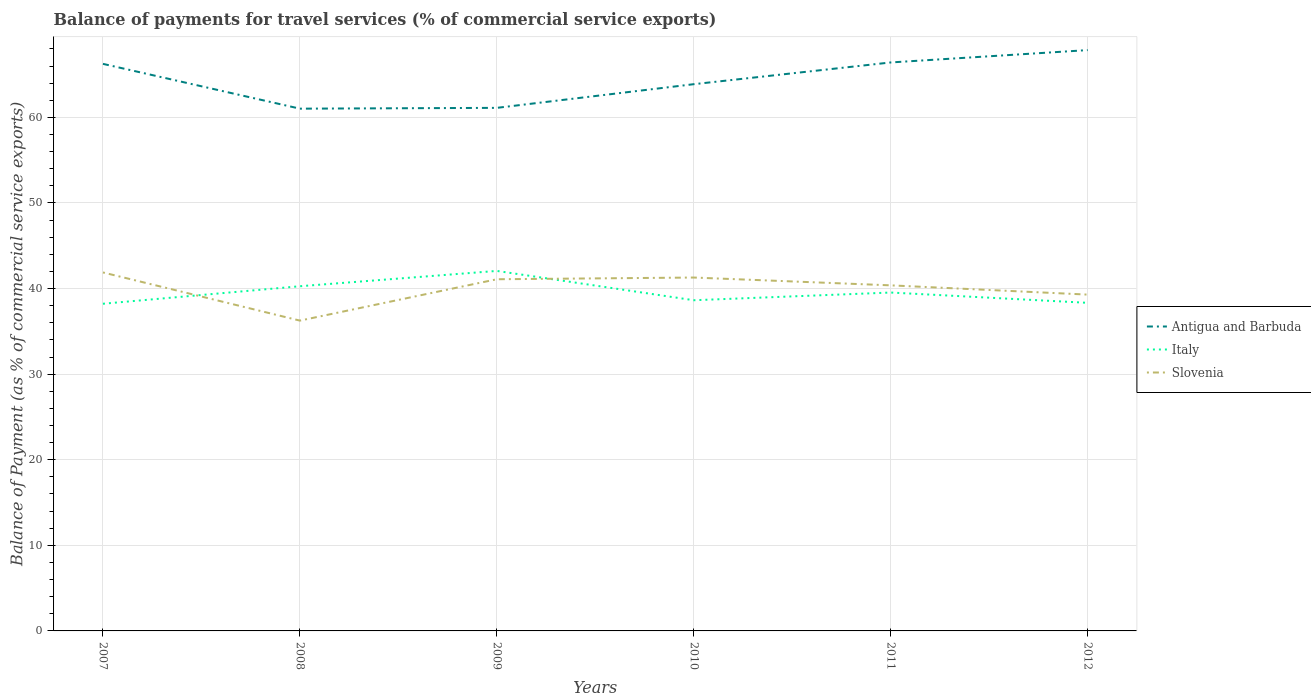How many different coloured lines are there?
Your answer should be compact. 3. Is the number of lines equal to the number of legend labels?
Ensure brevity in your answer.  Yes. Across all years, what is the maximum balance of payments for travel services in Antigua and Barbuda?
Your answer should be very brief. 61.02. In which year was the balance of payments for travel services in Italy maximum?
Give a very brief answer. 2007. What is the total balance of payments for travel services in Italy in the graph?
Your answer should be very brief. 1.63. What is the difference between the highest and the second highest balance of payments for travel services in Italy?
Give a very brief answer. 3.84. What is the difference between the highest and the lowest balance of payments for travel services in Antigua and Barbuda?
Provide a succinct answer. 3. How many lines are there?
Your answer should be compact. 3. How many years are there in the graph?
Offer a very short reply. 6. What is the difference between two consecutive major ticks on the Y-axis?
Keep it short and to the point. 10. Does the graph contain any zero values?
Ensure brevity in your answer.  No. Does the graph contain grids?
Offer a terse response. Yes. Where does the legend appear in the graph?
Give a very brief answer. Center right. How many legend labels are there?
Your answer should be compact. 3. What is the title of the graph?
Keep it short and to the point. Balance of payments for travel services (% of commercial service exports). Does "Malta" appear as one of the legend labels in the graph?
Provide a short and direct response. No. What is the label or title of the X-axis?
Your answer should be compact. Years. What is the label or title of the Y-axis?
Your answer should be compact. Balance of Payment (as % of commercial service exports). What is the Balance of Payment (as % of commercial service exports) in Antigua and Barbuda in 2007?
Keep it short and to the point. 66.25. What is the Balance of Payment (as % of commercial service exports) in Italy in 2007?
Ensure brevity in your answer.  38.22. What is the Balance of Payment (as % of commercial service exports) in Slovenia in 2007?
Your response must be concise. 41.88. What is the Balance of Payment (as % of commercial service exports) of Antigua and Barbuda in 2008?
Give a very brief answer. 61.02. What is the Balance of Payment (as % of commercial service exports) of Italy in 2008?
Your answer should be compact. 40.27. What is the Balance of Payment (as % of commercial service exports) of Slovenia in 2008?
Offer a terse response. 36.25. What is the Balance of Payment (as % of commercial service exports) in Antigua and Barbuda in 2009?
Offer a very short reply. 61.11. What is the Balance of Payment (as % of commercial service exports) of Italy in 2009?
Offer a very short reply. 42.06. What is the Balance of Payment (as % of commercial service exports) of Slovenia in 2009?
Make the answer very short. 41.09. What is the Balance of Payment (as % of commercial service exports) in Antigua and Barbuda in 2010?
Keep it short and to the point. 63.88. What is the Balance of Payment (as % of commercial service exports) in Italy in 2010?
Give a very brief answer. 38.64. What is the Balance of Payment (as % of commercial service exports) in Slovenia in 2010?
Your answer should be very brief. 41.29. What is the Balance of Payment (as % of commercial service exports) of Antigua and Barbuda in 2011?
Provide a short and direct response. 66.42. What is the Balance of Payment (as % of commercial service exports) of Italy in 2011?
Offer a very short reply. 39.53. What is the Balance of Payment (as % of commercial service exports) in Slovenia in 2011?
Provide a short and direct response. 40.37. What is the Balance of Payment (as % of commercial service exports) in Antigua and Barbuda in 2012?
Provide a succinct answer. 67.86. What is the Balance of Payment (as % of commercial service exports) in Italy in 2012?
Keep it short and to the point. 38.33. What is the Balance of Payment (as % of commercial service exports) of Slovenia in 2012?
Offer a very short reply. 39.29. Across all years, what is the maximum Balance of Payment (as % of commercial service exports) in Antigua and Barbuda?
Provide a short and direct response. 67.86. Across all years, what is the maximum Balance of Payment (as % of commercial service exports) in Italy?
Keep it short and to the point. 42.06. Across all years, what is the maximum Balance of Payment (as % of commercial service exports) of Slovenia?
Make the answer very short. 41.88. Across all years, what is the minimum Balance of Payment (as % of commercial service exports) of Antigua and Barbuda?
Your answer should be very brief. 61.02. Across all years, what is the minimum Balance of Payment (as % of commercial service exports) in Italy?
Give a very brief answer. 38.22. Across all years, what is the minimum Balance of Payment (as % of commercial service exports) of Slovenia?
Make the answer very short. 36.25. What is the total Balance of Payment (as % of commercial service exports) in Antigua and Barbuda in the graph?
Your response must be concise. 386.53. What is the total Balance of Payment (as % of commercial service exports) of Italy in the graph?
Ensure brevity in your answer.  237.06. What is the total Balance of Payment (as % of commercial service exports) in Slovenia in the graph?
Offer a terse response. 240.17. What is the difference between the Balance of Payment (as % of commercial service exports) of Antigua and Barbuda in 2007 and that in 2008?
Your answer should be very brief. 5.23. What is the difference between the Balance of Payment (as % of commercial service exports) of Italy in 2007 and that in 2008?
Offer a very short reply. -2.05. What is the difference between the Balance of Payment (as % of commercial service exports) in Slovenia in 2007 and that in 2008?
Offer a terse response. 5.63. What is the difference between the Balance of Payment (as % of commercial service exports) in Antigua and Barbuda in 2007 and that in 2009?
Provide a succinct answer. 5.14. What is the difference between the Balance of Payment (as % of commercial service exports) of Italy in 2007 and that in 2009?
Provide a succinct answer. -3.84. What is the difference between the Balance of Payment (as % of commercial service exports) of Slovenia in 2007 and that in 2009?
Give a very brief answer. 0.79. What is the difference between the Balance of Payment (as % of commercial service exports) of Antigua and Barbuda in 2007 and that in 2010?
Offer a terse response. 2.37. What is the difference between the Balance of Payment (as % of commercial service exports) in Italy in 2007 and that in 2010?
Your answer should be very brief. -0.41. What is the difference between the Balance of Payment (as % of commercial service exports) of Slovenia in 2007 and that in 2010?
Give a very brief answer. 0.59. What is the difference between the Balance of Payment (as % of commercial service exports) in Antigua and Barbuda in 2007 and that in 2011?
Provide a succinct answer. -0.17. What is the difference between the Balance of Payment (as % of commercial service exports) of Italy in 2007 and that in 2011?
Provide a short and direct response. -1.31. What is the difference between the Balance of Payment (as % of commercial service exports) of Slovenia in 2007 and that in 2011?
Ensure brevity in your answer.  1.51. What is the difference between the Balance of Payment (as % of commercial service exports) of Antigua and Barbuda in 2007 and that in 2012?
Provide a succinct answer. -1.61. What is the difference between the Balance of Payment (as % of commercial service exports) in Italy in 2007 and that in 2012?
Make the answer very short. -0.11. What is the difference between the Balance of Payment (as % of commercial service exports) of Slovenia in 2007 and that in 2012?
Your response must be concise. 2.59. What is the difference between the Balance of Payment (as % of commercial service exports) in Antigua and Barbuda in 2008 and that in 2009?
Offer a terse response. -0.09. What is the difference between the Balance of Payment (as % of commercial service exports) of Italy in 2008 and that in 2009?
Offer a terse response. -1.79. What is the difference between the Balance of Payment (as % of commercial service exports) of Slovenia in 2008 and that in 2009?
Give a very brief answer. -4.83. What is the difference between the Balance of Payment (as % of commercial service exports) of Antigua and Barbuda in 2008 and that in 2010?
Provide a short and direct response. -2.86. What is the difference between the Balance of Payment (as % of commercial service exports) of Italy in 2008 and that in 2010?
Give a very brief answer. 1.63. What is the difference between the Balance of Payment (as % of commercial service exports) of Slovenia in 2008 and that in 2010?
Offer a terse response. -5.03. What is the difference between the Balance of Payment (as % of commercial service exports) in Antigua and Barbuda in 2008 and that in 2011?
Offer a very short reply. -5.4. What is the difference between the Balance of Payment (as % of commercial service exports) of Italy in 2008 and that in 2011?
Your response must be concise. 0.74. What is the difference between the Balance of Payment (as % of commercial service exports) in Slovenia in 2008 and that in 2011?
Ensure brevity in your answer.  -4.12. What is the difference between the Balance of Payment (as % of commercial service exports) of Antigua and Barbuda in 2008 and that in 2012?
Your response must be concise. -6.84. What is the difference between the Balance of Payment (as % of commercial service exports) in Italy in 2008 and that in 2012?
Your response must be concise. 1.94. What is the difference between the Balance of Payment (as % of commercial service exports) of Slovenia in 2008 and that in 2012?
Your answer should be very brief. -3.04. What is the difference between the Balance of Payment (as % of commercial service exports) in Antigua and Barbuda in 2009 and that in 2010?
Ensure brevity in your answer.  -2.77. What is the difference between the Balance of Payment (as % of commercial service exports) in Italy in 2009 and that in 2010?
Offer a very short reply. 3.42. What is the difference between the Balance of Payment (as % of commercial service exports) of Slovenia in 2009 and that in 2010?
Ensure brevity in your answer.  -0.2. What is the difference between the Balance of Payment (as % of commercial service exports) of Antigua and Barbuda in 2009 and that in 2011?
Give a very brief answer. -5.3. What is the difference between the Balance of Payment (as % of commercial service exports) of Italy in 2009 and that in 2011?
Ensure brevity in your answer.  2.53. What is the difference between the Balance of Payment (as % of commercial service exports) in Slovenia in 2009 and that in 2011?
Your answer should be compact. 0.71. What is the difference between the Balance of Payment (as % of commercial service exports) in Antigua and Barbuda in 2009 and that in 2012?
Your answer should be very brief. -6.75. What is the difference between the Balance of Payment (as % of commercial service exports) in Italy in 2009 and that in 2012?
Make the answer very short. 3.73. What is the difference between the Balance of Payment (as % of commercial service exports) of Slovenia in 2009 and that in 2012?
Make the answer very short. 1.79. What is the difference between the Balance of Payment (as % of commercial service exports) in Antigua and Barbuda in 2010 and that in 2011?
Ensure brevity in your answer.  -2.54. What is the difference between the Balance of Payment (as % of commercial service exports) in Italy in 2010 and that in 2011?
Offer a very short reply. -0.9. What is the difference between the Balance of Payment (as % of commercial service exports) in Slovenia in 2010 and that in 2011?
Ensure brevity in your answer.  0.91. What is the difference between the Balance of Payment (as % of commercial service exports) of Antigua and Barbuda in 2010 and that in 2012?
Give a very brief answer. -3.98. What is the difference between the Balance of Payment (as % of commercial service exports) in Italy in 2010 and that in 2012?
Give a very brief answer. 0.3. What is the difference between the Balance of Payment (as % of commercial service exports) in Slovenia in 2010 and that in 2012?
Offer a terse response. 1.99. What is the difference between the Balance of Payment (as % of commercial service exports) in Antigua and Barbuda in 2011 and that in 2012?
Make the answer very short. -1.44. What is the difference between the Balance of Payment (as % of commercial service exports) in Italy in 2011 and that in 2012?
Offer a terse response. 1.2. What is the difference between the Balance of Payment (as % of commercial service exports) of Slovenia in 2011 and that in 2012?
Your answer should be compact. 1.08. What is the difference between the Balance of Payment (as % of commercial service exports) in Antigua and Barbuda in 2007 and the Balance of Payment (as % of commercial service exports) in Italy in 2008?
Your answer should be very brief. 25.98. What is the difference between the Balance of Payment (as % of commercial service exports) in Antigua and Barbuda in 2007 and the Balance of Payment (as % of commercial service exports) in Slovenia in 2008?
Your answer should be compact. 30. What is the difference between the Balance of Payment (as % of commercial service exports) in Italy in 2007 and the Balance of Payment (as % of commercial service exports) in Slovenia in 2008?
Your answer should be very brief. 1.97. What is the difference between the Balance of Payment (as % of commercial service exports) of Antigua and Barbuda in 2007 and the Balance of Payment (as % of commercial service exports) of Italy in 2009?
Give a very brief answer. 24.19. What is the difference between the Balance of Payment (as % of commercial service exports) in Antigua and Barbuda in 2007 and the Balance of Payment (as % of commercial service exports) in Slovenia in 2009?
Keep it short and to the point. 25.16. What is the difference between the Balance of Payment (as % of commercial service exports) in Italy in 2007 and the Balance of Payment (as % of commercial service exports) in Slovenia in 2009?
Keep it short and to the point. -2.86. What is the difference between the Balance of Payment (as % of commercial service exports) in Antigua and Barbuda in 2007 and the Balance of Payment (as % of commercial service exports) in Italy in 2010?
Offer a terse response. 27.62. What is the difference between the Balance of Payment (as % of commercial service exports) of Antigua and Barbuda in 2007 and the Balance of Payment (as % of commercial service exports) of Slovenia in 2010?
Ensure brevity in your answer.  24.96. What is the difference between the Balance of Payment (as % of commercial service exports) of Italy in 2007 and the Balance of Payment (as % of commercial service exports) of Slovenia in 2010?
Give a very brief answer. -3.06. What is the difference between the Balance of Payment (as % of commercial service exports) of Antigua and Barbuda in 2007 and the Balance of Payment (as % of commercial service exports) of Italy in 2011?
Ensure brevity in your answer.  26.72. What is the difference between the Balance of Payment (as % of commercial service exports) of Antigua and Barbuda in 2007 and the Balance of Payment (as % of commercial service exports) of Slovenia in 2011?
Make the answer very short. 25.88. What is the difference between the Balance of Payment (as % of commercial service exports) in Italy in 2007 and the Balance of Payment (as % of commercial service exports) in Slovenia in 2011?
Provide a succinct answer. -2.15. What is the difference between the Balance of Payment (as % of commercial service exports) of Antigua and Barbuda in 2007 and the Balance of Payment (as % of commercial service exports) of Italy in 2012?
Your answer should be compact. 27.92. What is the difference between the Balance of Payment (as % of commercial service exports) of Antigua and Barbuda in 2007 and the Balance of Payment (as % of commercial service exports) of Slovenia in 2012?
Your response must be concise. 26.96. What is the difference between the Balance of Payment (as % of commercial service exports) of Italy in 2007 and the Balance of Payment (as % of commercial service exports) of Slovenia in 2012?
Provide a succinct answer. -1.07. What is the difference between the Balance of Payment (as % of commercial service exports) of Antigua and Barbuda in 2008 and the Balance of Payment (as % of commercial service exports) of Italy in 2009?
Give a very brief answer. 18.96. What is the difference between the Balance of Payment (as % of commercial service exports) in Antigua and Barbuda in 2008 and the Balance of Payment (as % of commercial service exports) in Slovenia in 2009?
Ensure brevity in your answer.  19.93. What is the difference between the Balance of Payment (as % of commercial service exports) in Italy in 2008 and the Balance of Payment (as % of commercial service exports) in Slovenia in 2009?
Provide a succinct answer. -0.82. What is the difference between the Balance of Payment (as % of commercial service exports) of Antigua and Barbuda in 2008 and the Balance of Payment (as % of commercial service exports) of Italy in 2010?
Your response must be concise. 22.38. What is the difference between the Balance of Payment (as % of commercial service exports) in Antigua and Barbuda in 2008 and the Balance of Payment (as % of commercial service exports) in Slovenia in 2010?
Your answer should be very brief. 19.73. What is the difference between the Balance of Payment (as % of commercial service exports) of Italy in 2008 and the Balance of Payment (as % of commercial service exports) of Slovenia in 2010?
Your response must be concise. -1.02. What is the difference between the Balance of Payment (as % of commercial service exports) of Antigua and Barbuda in 2008 and the Balance of Payment (as % of commercial service exports) of Italy in 2011?
Make the answer very short. 21.48. What is the difference between the Balance of Payment (as % of commercial service exports) of Antigua and Barbuda in 2008 and the Balance of Payment (as % of commercial service exports) of Slovenia in 2011?
Provide a succinct answer. 20.64. What is the difference between the Balance of Payment (as % of commercial service exports) of Italy in 2008 and the Balance of Payment (as % of commercial service exports) of Slovenia in 2011?
Your response must be concise. -0.1. What is the difference between the Balance of Payment (as % of commercial service exports) of Antigua and Barbuda in 2008 and the Balance of Payment (as % of commercial service exports) of Italy in 2012?
Ensure brevity in your answer.  22.68. What is the difference between the Balance of Payment (as % of commercial service exports) of Antigua and Barbuda in 2008 and the Balance of Payment (as % of commercial service exports) of Slovenia in 2012?
Offer a terse response. 21.72. What is the difference between the Balance of Payment (as % of commercial service exports) of Italy in 2008 and the Balance of Payment (as % of commercial service exports) of Slovenia in 2012?
Make the answer very short. 0.98. What is the difference between the Balance of Payment (as % of commercial service exports) of Antigua and Barbuda in 2009 and the Balance of Payment (as % of commercial service exports) of Italy in 2010?
Offer a terse response. 22.48. What is the difference between the Balance of Payment (as % of commercial service exports) of Antigua and Barbuda in 2009 and the Balance of Payment (as % of commercial service exports) of Slovenia in 2010?
Keep it short and to the point. 19.82. What is the difference between the Balance of Payment (as % of commercial service exports) in Italy in 2009 and the Balance of Payment (as % of commercial service exports) in Slovenia in 2010?
Your answer should be very brief. 0.77. What is the difference between the Balance of Payment (as % of commercial service exports) of Antigua and Barbuda in 2009 and the Balance of Payment (as % of commercial service exports) of Italy in 2011?
Your answer should be very brief. 21.58. What is the difference between the Balance of Payment (as % of commercial service exports) in Antigua and Barbuda in 2009 and the Balance of Payment (as % of commercial service exports) in Slovenia in 2011?
Your answer should be very brief. 20.74. What is the difference between the Balance of Payment (as % of commercial service exports) of Italy in 2009 and the Balance of Payment (as % of commercial service exports) of Slovenia in 2011?
Your answer should be very brief. 1.69. What is the difference between the Balance of Payment (as % of commercial service exports) in Antigua and Barbuda in 2009 and the Balance of Payment (as % of commercial service exports) in Italy in 2012?
Your response must be concise. 22.78. What is the difference between the Balance of Payment (as % of commercial service exports) of Antigua and Barbuda in 2009 and the Balance of Payment (as % of commercial service exports) of Slovenia in 2012?
Make the answer very short. 21.82. What is the difference between the Balance of Payment (as % of commercial service exports) in Italy in 2009 and the Balance of Payment (as % of commercial service exports) in Slovenia in 2012?
Provide a short and direct response. 2.77. What is the difference between the Balance of Payment (as % of commercial service exports) of Antigua and Barbuda in 2010 and the Balance of Payment (as % of commercial service exports) of Italy in 2011?
Offer a terse response. 24.34. What is the difference between the Balance of Payment (as % of commercial service exports) of Antigua and Barbuda in 2010 and the Balance of Payment (as % of commercial service exports) of Slovenia in 2011?
Make the answer very short. 23.5. What is the difference between the Balance of Payment (as % of commercial service exports) in Italy in 2010 and the Balance of Payment (as % of commercial service exports) in Slovenia in 2011?
Give a very brief answer. -1.74. What is the difference between the Balance of Payment (as % of commercial service exports) in Antigua and Barbuda in 2010 and the Balance of Payment (as % of commercial service exports) in Italy in 2012?
Keep it short and to the point. 25.54. What is the difference between the Balance of Payment (as % of commercial service exports) in Antigua and Barbuda in 2010 and the Balance of Payment (as % of commercial service exports) in Slovenia in 2012?
Make the answer very short. 24.58. What is the difference between the Balance of Payment (as % of commercial service exports) of Italy in 2010 and the Balance of Payment (as % of commercial service exports) of Slovenia in 2012?
Provide a short and direct response. -0.66. What is the difference between the Balance of Payment (as % of commercial service exports) of Antigua and Barbuda in 2011 and the Balance of Payment (as % of commercial service exports) of Italy in 2012?
Offer a terse response. 28.08. What is the difference between the Balance of Payment (as % of commercial service exports) of Antigua and Barbuda in 2011 and the Balance of Payment (as % of commercial service exports) of Slovenia in 2012?
Your answer should be very brief. 27.12. What is the difference between the Balance of Payment (as % of commercial service exports) of Italy in 2011 and the Balance of Payment (as % of commercial service exports) of Slovenia in 2012?
Offer a very short reply. 0.24. What is the average Balance of Payment (as % of commercial service exports) in Antigua and Barbuda per year?
Give a very brief answer. 64.42. What is the average Balance of Payment (as % of commercial service exports) in Italy per year?
Offer a very short reply. 39.51. What is the average Balance of Payment (as % of commercial service exports) of Slovenia per year?
Give a very brief answer. 40.03. In the year 2007, what is the difference between the Balance of Payment (as % of commercial service exports) in Antigua and Barbuda and Balance of Payment (as % of commercial service exports) in Italy?
Give a very brief answer. 28.03. In the year 2007, what is the difference between the Balance of Payment (as % of commercial service exports) in Antigua and Barbuda and Balance of Payment (as % of commercial service exports) in Slovenia?
Your response must be concise. 24.37. In the year 2007, what is the difference between the Balance of Payment (as % of commercial service exports) of Italy and Balance of Payment (as % of commercial service exports) of Slovenia?
Your answer should be very brief. -3.66. In the year 2008, what is the difference between the Balance of Payment (as % of commercial service exports) of Antigua and Barbuda and Balance of Payment (as % of commercial service exports) of Italy?
Provide a succinct answer. 20.75. In the year 2008, what is the difference between the Balance of Payment (as % of commercial service exports) of Antigua and Barbuda and Balance of Payment (as % of commercial service exports) of Slovenia?
Provide a short and direct response. 24.76. In the year 2008, what is the difference between the Balance of Payment (as % of commercial service exports) of Italy and Balance of Payment (as % of commercial service exports) of Slovenia?
Your answer should be compact. 4.02. In the year 2009, what is the difference between the Balance of Payment (as % of commercial service exports) in Antigua and Barbuda and Balance of Payment (as % of commercial service exports) in Italy?
Ensure brevity in your answer.  19.05. In the year 2009, what is the difference between the Balance of Payment (as % of commercial service exports) in Antigua and Barbuda and Balance of Payment (as % of commercial service exports) in Slovenia?
Your response must be concise. 20.02. In the year 2009, what is the difference between the Balance of Payment (as % of commercial service exports) in Italy and Balance of Payment (as % of commercial service exports) in Slovenia?
Give a very brief answer. 0.97. In the year 2010, what is the difference between the Balance of Payment (as % of commercial service exports) of Antigua and Barbuda and Balance of Payment (as % of commercial service exports) of Italy?
Keep it short and to the point. 25.24. In the year 2010, what is the difference between the Balance of Payment (as % of commercial service exports) in Antigua and Barbuda and Balance of Payment (as % of commercial service exports) in Slovenia?
Provide a short and direct response. 22.59. In the year 2010, what is the difference between the Balance of Payment (as % of commercial service exports) of Italy and Balance of Payment (as % of commercial service exports) of Slovenia?
Give a very brief answer. -2.65. In the year 2011, what is the difference between the Balance of Payment (as % of commercial service exports) in Antigua and Barbuda and Balance of Payment (as % of commercial service exports) in Italy?
Provide a succinct answer. 26.88. In the year 2011, what is the difference between the Balance of Payment (as % of commercial service exports) in Antigua and Barbuda and Balance of Payment (as % of commercial service exports) in Slovenia?
Offer a very short reply. 26.04. In the year 2011, what is the difference between the Balance of Payment (as % of commercial service exports) in Italy and Balance of Payment (as % of commercial service exports) in Slovenia?
Provide a short and direct response. -0.84. In the year 2012, what is the difference between the Balance of Payment (as % of commercial service exports) of Antigua and Barbuda and Balance of Payment (as % of commercial service exports) of Italy?
Provide a short and direct response. 29.53. In the year 2012, what is the difference between the Balance of Payment (as % of commercial service exports) of Antigua and Barbuda and Balance of Payment (as % of commercial service exports) of Slovenia?
Give a very brief answer. 28.57. In the year 2012, what is the difference between the Balance of Payment (as % of commercial service exports) in Italy and Balance of Payment (as % of commercial service exports) in Slovenia?
Ensure brevity in your answer.  -0.96. What is the ratio of the Balance of Payment (as % of commercial service exports) in Antigua and Barbuda in 2007 to that in 2008?
Give a very brief answer. 1.09. What is the ratio of the Balance of Payment (as % of commercial service exports) in Italy in 2007 to that in 2008?
Provide a succinct answer. 0.95. What is the ratio of the Balance of Payment (as % of commercial service exports) in Slovenia in 2007 to that in 2008?
Keep it short and to the point. 1.16. What is the ratio of the Balance of Payment (as % of commercial service exports) in Antigua and Barbuda in 2007 to that in 2009?
Give a very brief answer. 1.08. What is the ratio of the Balance of Payment (as % of commercial service exports) in Italy in 2007 to that in 2009?
Your answer should be very brief. 0.91. What is the ratio of the Balance of Payment (as % of commercial service exports) of Slovenia in 2007 to that in 2009?
Provide a succinct answer. 1.02. What is the ratio of the Balance of Payment (as % of commercial service exports) in Antigua and Barbuda in 2007 to that in 2010?
Ensure brevity in your answer.  1.04. What is the ratio of the Balance of Payment (as % of commercial service exports) of Slovenia in 2007 to that in 2010?
Provide a succinct answer. 1.01. What is the ratio of the Balance of Payment (as % of commercial service exports) of Italy in 2007 to that in 2011?
Provide a short and direct response. 0.97. What is the ratio of the Balance of Payment (as % of commercial service exports) in Slovenia in 2007 to that in 2011?
Make the answer very short. 1.04. What is the ratio of the Balance of Payment (as % of commercial service exports) in Antigua and Barbuda in 2007 to that in 2012?
Provide a short and direct response. 0.98. What is the ratio of the Balance of Payment (as % of commercial service exports) in Slovenia in 2007 to that in 2012?
Your response must be concise. 1.07. What is the ratio of the Balance of Payment (as % of commercial service exports) in Antigua and Barbuda in 2008 to that in 2009?
Offer a very short reply. 1. What is the ratio of the Balance of Payment (as % of commercial service exports) in Italy in 2008 to that in 2009?
Provide a short and direct response. 0.96. What is the ratio of the Balance of Payment (as % of commercial service exports) in Slovenia in 2008 to that in 2009?
Ensure brevity in your answer.  0.88. What is the ratio of the Balance of Payment (as % of commercial service exports) of Antigua and Barbuda in 2008 to that in 2010?
Your answer should be compact. 0.96. What is the ratio of the Balance of Payment (as % of commercial service exports) of Italy in 2008 to that in 2010?
Provide a short and direct response. 1.04. What is the ratio of the Balance of Payment (as % of commercial service exports) of Slovenia in 2008 to that in 2010?
Offer a terse response. 0.88. What is the ratio of the Balance of Payment (as % of commercial service exports) of Antigua and Barbuda in 2008 to that in 2011?
Your answer should be very brief. 0.92. What is the ratio of the Balance of Payment (as % of commercial service exports) in Italy in 2008 to that in 2011?
Give a very brief answer. 1.02. What is the ratio of the Balance of Payment (as % of commercial service exports) of Slovenia in 2008 to that in 2011?
Make the answer very short. 0.9. What is the ratio of the Balance of Payment (as % of commercial service exports) of Antigua and Barbuda in 2008 to that in 2012?
Your answer should be compact. 0.9. What is the ratio of the Balance of Payment (as % of commercial service exports) of Italy in 2008 to that in 2012?
Your answer should be compact. 1.05. What is the ratio of the Balance of Payment (as % of commercial service exports) in Slovenia in 2008 to that in 2012?
Your answer should be very brief. 0.92. What is the ratio of the Balance of Payment (as % of commercial service exports) of Antigua and Barbuda in 2009 to that in 2010?
Offer a very short reply. 0.96. What is the ratio of the Balance of Payment (as % of commercial service exports) in Italy in 2009 to that in 2010?
Offer a very short reply. 1.09. What is the ratio of the Balance of Payment (as % of commercial service exports) of Antigua and Barbuda in 2009 to that in 2011?
Your answer should be compact. 0.92. What is the ratio of the Balance of Payment (as % of commercial service exports) in Italy in 2009 to that in 2011?
Keep it short and to the point. 1.06. What is the ratio of the Balance of Payment (as % of commercial service exports) of Slovenia in 2009 to that in 2011?
Make the answer very short. 1.02. What is the ratio of the Balance of Payment (as % of commercial service exports) of Antigua and Barbuda in 2009 to that in 2012?
Provide a succinct answer. 0.9. What is the ratio of the Balance of Payment (as % of commercial service exports) of Italy in 2009 to that in 2012?
Provide a succinct answer. 1.1. What is the ratio of the Balance of Payment (as % of commercial service exports) of Slovenia in 2009 to that in 2012?
Your answer should be very brief. 1.05. What is the ratio of the Balance of Payment (as % of commercial service exports) of Antigua and Barbuda in 2010 to that in 2011?
Provide a short and direct response. 0.96. What is the ratio of the Balance of Payment (as % of commercial service exports) in Italy in 2010 to that in 2011?
Keep it short and to the point. 0.98. What is the ratio of the Balance of Payment (as % of commercial service exports) of Slovenia in 2010 to that in 2011?
Your answer should be very brief. 1.02. What is the ratio of the Balance of Payment (as % of commercial service exports) in Antigua and Barbuda in 2010 to that in 2012?
Your response must be concise. 0.94. What is the ratio of the Balance of Payment (as % of commercial service exports) of Italy in 2010 to that in 2012?
Your answer should be very brief. 1.01. What is the ratio of the Balance of Payment (as % of commercial service exports) in Slovenia in 2010 to that in 2012?
Provide a succinct answer. 1.05. What is the ratio of the Balance of Payment (as % of commercial service exports) of Antigua and Barbuda in 2011 to that in 2012?
Ensure brevity in your answer.  0.98. What is the ratio of the Balance of Payment (as % of commercial service exports) of Italy in 2011 to that in 2012?
Keep it short and to the point. 1.03. What is the ratio of the Balance of Payment (as % of commercial service exports) in Slovenia in 2011 to that in 2012?
Provide a short and direct response. 1.03. What is the difference between the highest and the second highest Balance of Payment (as % of commercial service exports) of Antigua and Barbuda?
Ensure brevity in your answer.  1.44. What is the difference between the highest and the second highest Balance of Payment (as % of commercial service exports) in Italy?
Provide a short and direct response. 1.79. What is the difference between the highest and the second highest Balance of Payment (as % of commercial service exports) in Slovenia?
Provide a succinct answer. 0.59. What is the difference between the highest and the lowest Balance of Payment (as % of commercial service exports) of Antigua and Barbuda?
Keep it short and to the point. 6.84. What is the difference between the highest and the lowest Balance of Payment (as % of commercial service exports) in Italy?
Ensure brevity in your answer.  3.84. What is the difference between the highest and the lowest Balance of Payment (as % of commercial service exports) of Slovenia?
Your answer should be very brief. 5.63. 